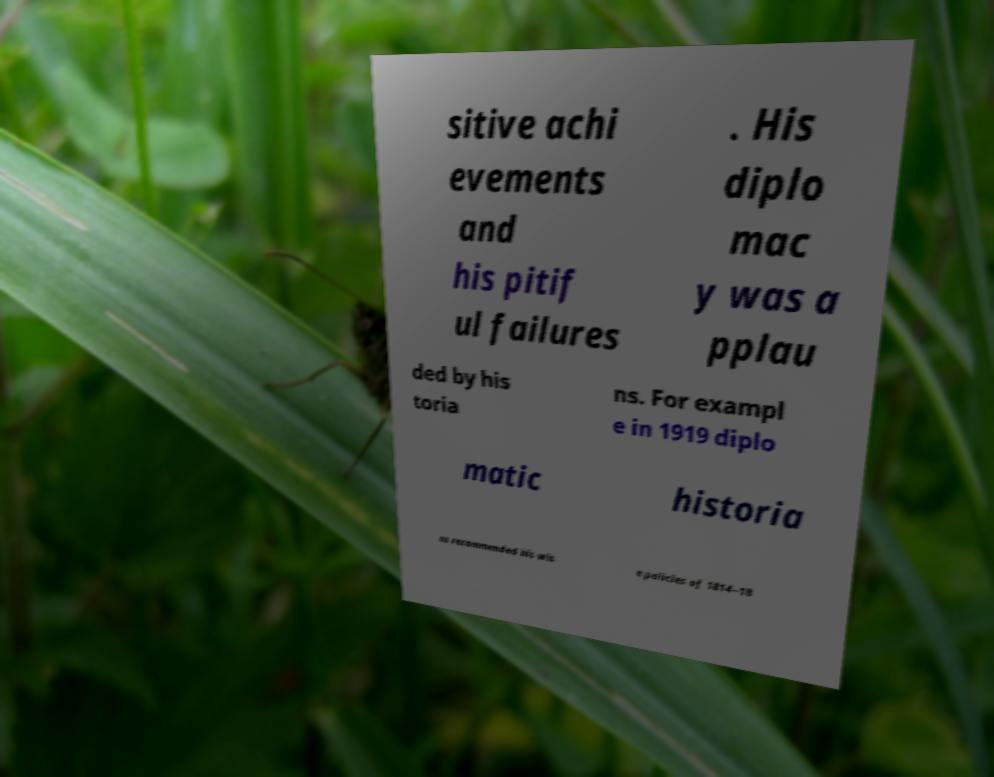Can you read and provide the text displayed in the image?This photo seems to have some interesting text. Can you extract and type it out for me? sitive achi evements and his pitif ul failures . His diplo mac y was a pplau ded by his toria ns. For exampl e in 1919 diplo matic historia ns recommended his wis e policies of 1814–18 